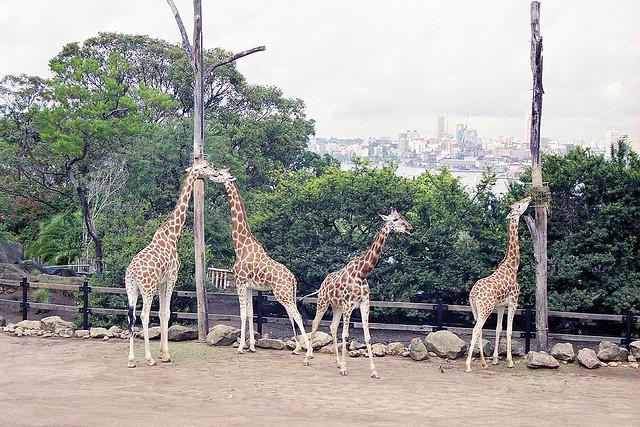How many giraffes are there?
Write a very short answer. 4. Are these giraffes in the wild?
Concise answer only. No. What animals are in the photo?
Answer briefly. Giraffes. 